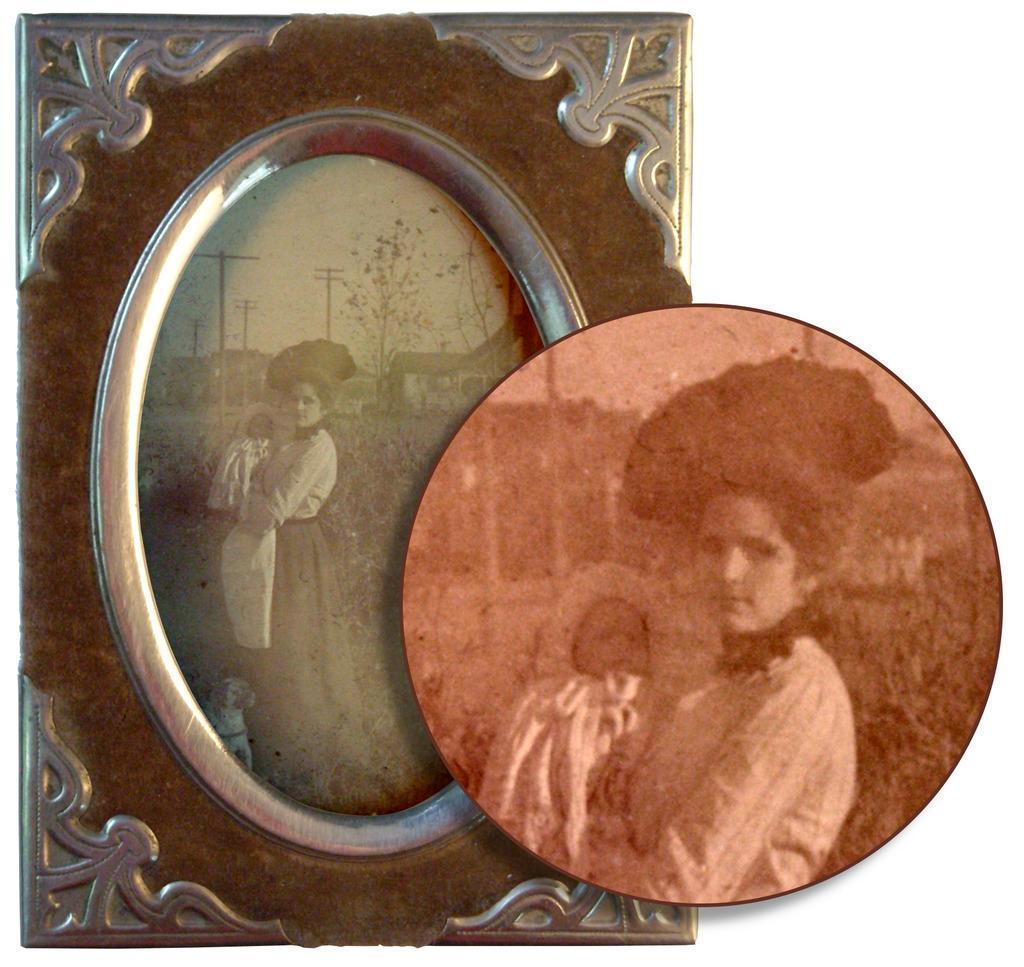Can you describe this image briefly? In this image there are photoframeś, there is a person standing and carrying another person, there is a dog, there are poleś behind the person, there are houses, there are plantś, there is the sky. 